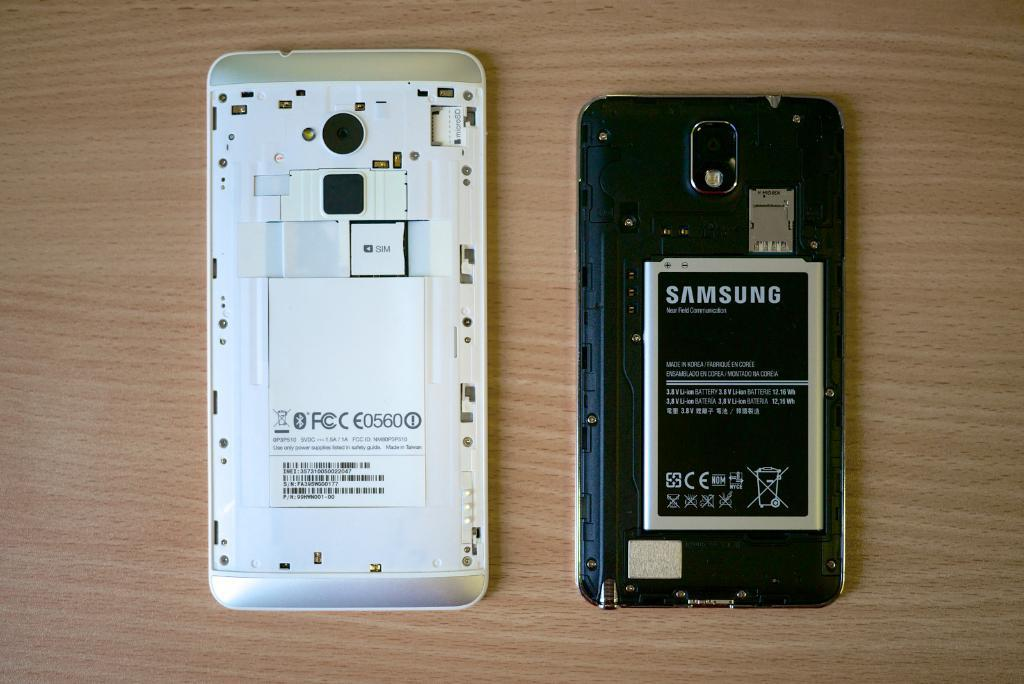Provide a one-sentence caption for the provided image. An open old samsung phone showing the inside battery pack. 